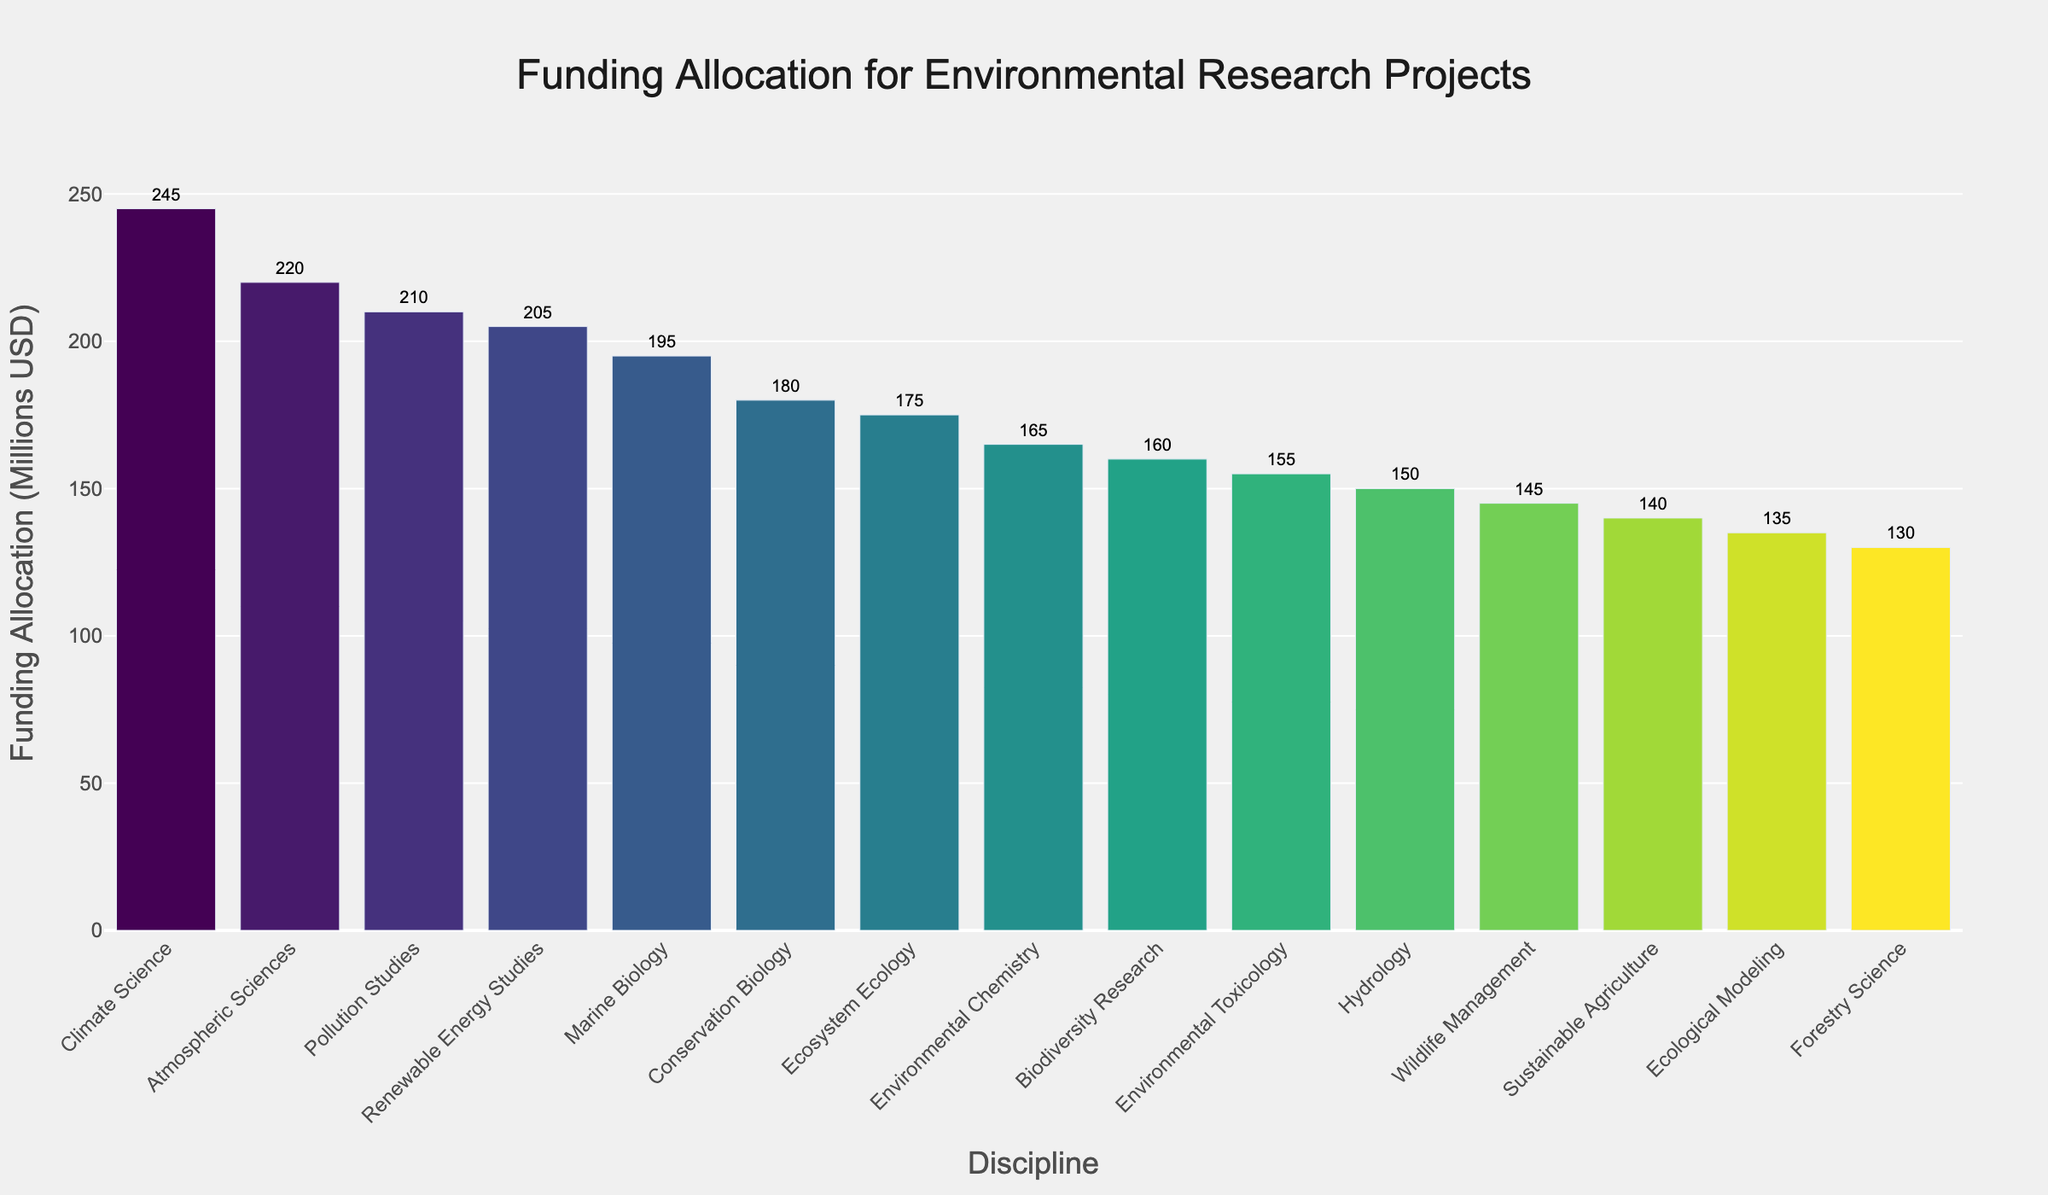Which discipline received the most funding allocation? The bar chart shows Climate Science with the tallest bar, indicating it received the highest funding.
Answer: Climate Science What is the funding difference between Atmospheric Sciences and Conservation Biology? The funding for Atmospheric Sciences is 220 million USD, and for Conservation Biology, it is 180 million USD. The difference is 220 - 180 = 40 million USD.
Answer: 40 million USD How much total funding was allocated to the top three disciplines? The top three disciplines by funding are Climate Science (245 million USD), Atmospheric Sciences (220 million USD), and Pollution Studies (210 million USD). Adding these gives a total of 245 + 220 + 210 = 675 million USD.
Answer: 675 million USD Which disciplines received less funding than Pollution Studies but more than Biodiversity Research? Pollution Studies received 210 million USD, and Biodiversity Research received 160 million USD. Disciplines that received less than 210 million but more than 160 million USD are Marine Biology (195 million USD) and Renewable Energy Studies (205 million USD).
Answer: Marine Biology, Renewable Energy Studies What is the average funding allocation for all disciplines? Summing all the funding allocations (245 + 180 + 210 + 135 + 195 + 165 + 150 + 220 + 175 + 160 + 140 + 130 + 155 + 205 + 145) gives a total of 2,710 million USD. There are 15 disciplines, so the average is 2,710 / 15 ≈ 180.67 million USD.
Answer: 180.67 million USD Which discipline has the smallest funding allocation, and how much is it? The shortest bar in the bar chart represents Forestry Science, which has the smallest funding allocation of 130 million USD.
Answer: Forestry Science, 130 million USD Is the funding allocation for Marine Biology higher or lower than that for Pollution Studies? The bar representing Marine Biology is shorter than the bar for Pollution Studies, indicating that Marine Biology received less funding.
Answer: Lower What is the combined funding allocation for Ecological Modeling and Environmental Toxicology? Ecological Modeling received 135 million USD, and Environmental Toxicology 155 million USD. Combined, they received 135 + 155 = 290 million USD.
Answer: 290 million USD Which two disciplines have the closest funding allocation, and what are their values? Biodiversity Research (160 million USD) and Environmental Chemistry (165 million USD) have the closest funding allocations, with a difference of only 5 million USD.
Answer: Biodiversity Research (160 million USD), Environmental Chemistry (165 million USD) How does the funding allocation for Sustainable Agriculture compare to that for Wildlife Management? The bars for Sustainable Agriculture and Wildlife Management show that Sustainable Agriculture received 140 million USD, while Wildlife Management received 145 million USD. Sustainable Agriculture received less funding.
Answer: Sustainable Agriculture is less than Wildlife Management 